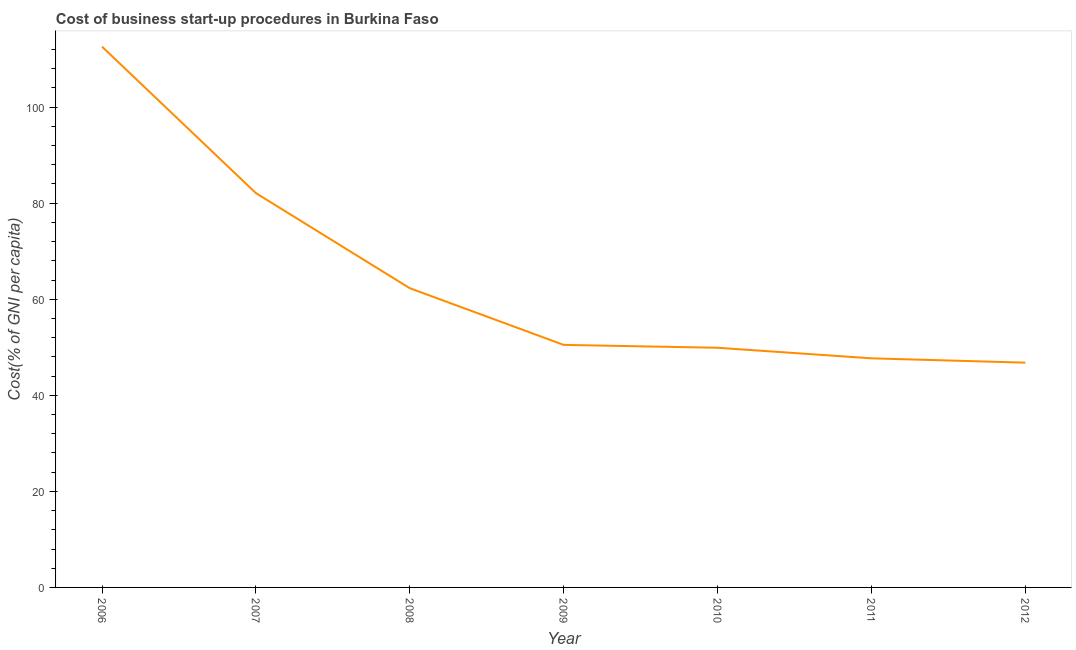What is the cost of business startup procedures in 2011?
Your answer should be very brief. 47.7. Across all years, what is the maximum cost of business startup procedures?
Your answer should be very brief. 112.6. Across all years, what is the minimum cost of business startup procedures?
Offer a very short reply. 46.8. In which year was the cost of business startup procedures minimum?
Offer a very short reply. 2012. What is the sum of the cost of business startup procedures?
Keep it short and to the point. 451.9. What is the difference between the cost of business startup procedures in 2007 and 2010?
Your response must be concise. 32.2. What is the average cost of business startup procedures per year?
Provide a short and direct response. 64.56. What is the median cost of business startup procedures?
Keep it short and to the point. 50.5. In how many years, is the cost of business startup procedures greater than 68 %?
Your answer should be very brief. 2. What is the ratio of the cost of business startup procedures in 2007 to that in 2008?
Keep it short and to the point. 1.32. Is the cost of business startup procedures in 2009 less than that in 2011?
Provide a succinct answer. No. Is the difference between the cost of business startup procedures in 2009 and 2010 greater than the difference between any two years?
Your answer should be very brief. No. What is the difference between the highest and the second highest cost of business startup procedures?
Provide a succinct answer. 30.5. What is the difference between the highest and the lowest cost of business startup procedures?
Your response must be concise. 65.8. Does the graph contain any zero values?
Provide a succinct answer. No. What is the title of the graph?
Give a very brief answer. Cost of business start-up procedures in Burkina Faso. What is the label or title of the Y-axis?
Keep it short and to the point. Cost(% of GNI per capita). What is the Cost(% of GNI per capita) of 2006?
Provide a short and direct response. 112.6. What is the Cost(% of GNI per capita) of 2007?
Your answer should be very brief. 82.1. What is the Cost(% of GNI per capita) in 2008?
Provide a short and direct response. 62.3. What is the Cost(% of GNI per capita) of 2009?
Your answer should be very brief. 50.5. What is the Cost(% of GNI per capita) of 2010?
Make the answer very short. 49.9. What is the Cost(% of GNI per capita) of 2011?
Offer a very short reply. 47.7. What is the Cost(% of GNI per capita) of 2012?
Provide a succinct answer. 46.8. What is the difference between the Cost(% of GNI per capita) in 2006 and 2007?
Your response must be concise. 30.5. What is the difference between the Cost(% of GNI per capita) in 2006 and 2008?
Ensure brevity in your answer.  50.3. What is the difference between the Cost(% of GNI per capita) in 2006 and 2009?
Provide a short and direct response. 62.1. What is the difference between the Cost(% of GNI per capita) in 2006 and 2010?
Offer a very short reply. 62.7. What is the difference between the Cost(% of GNI per capita) in 2006 and 2011?
Offer a very short reply. 64.9. What is the difference between the Cost(% of GNI per capita) in 2006 and 2012?
Ensure brevity in your answer.  65.8. What is the difference between the Cost(% of GNI per capita) in 2007 and 2008?
Your answer should be very brief. 19.8. What is the difference between the Cost(% of GNI per capita) in 2007 and 2009?
Your answer should be compact. 31.6. What is the difference between the Cost(% of GNI per capita) in 2007 and 2010?
Your response must be concise. 32.2. What is the difference between the Cost(% of GNI per capita) in 2007 and 2011?
Your answer should be very brief. 34.4. What is the difference between the Cost(% of GNI per capita) in 2007 and 2012?
Make the answer very short. 35.3. What is the difference between the Cost(% of GNI per capita) in 2008 and 2009?
Ensure brevity in your answer.  11.8. What is the difference between the Cost(% of GNI per capita) in 2008 and 2011?
Give a very brief answer. 14.6. What is the difference between the Cost(% of GNI per capita) in 2010 and 2011?
Your response must be concise. 2.2. What is the ratio of the Cost(% of GNI per capita) in 2006 to that in 2007?
Give a very brief answer. 1.37. What is the ratio of the Cost(% of GNI per capita) in 2006 to that in 2008?
Ensure brevity in your answer.  1.81. What is the ratio of the Cost(% of GNI per capita) in 2006 to that in 2009?
Your response must be concise. 2.23. What is the ratio of the Cost(% of GNI per capita) in 2006 to that in 2010?
Keep it short and to the point. 2.26. What is the ratio of the Cost(% of GNI per capita) in 2006 to that in 2011?
Provide a succinct answer. 2.36. What is the ratio of the Cost(% of GNI per capita) in 2006 to that in 2012?
Provide a succinct answer. 2.41. What is the ratio of the Cost(% of GNI per capita) in 2007 to that in 2008?
Your response must be concise. 1.32. What is the ratio of the Cost(% of GNI per capita) in 2007 to that in 2009?
Provide a short and direct response. 1.63. What is the ratio of the Cost(% of GNI per capita) in 2007 to that in 2010?
Make the answer very short. 1.65. What is the ratio of the Cost(% of GNI per capita) in 2007 to that in 2011?
Keep it short and to the point. 1.72. What is the ratio of the Cost(% of GNI per capita) in 2007 to that in 2012?
Your response must be concise. 1.75. What is the ratio of the Cost(% of GNI per capita) in 2008 to that in 2009?
Offer a terse response. 1.23. What is the ratio of the Cost(% of GNI per capita) in 2008 to that in 2010?
Your response must be concise. 1.25. What is the ratio of the Cost(% of GNI per capita) in 2008 to that in 2011?
Provide a short and direct response. 1.31. What is the ratio of the Cost(% of GNI per capita) in 2008 to that in 2012?
Provide a short and direct response. 1.33. What is the ratio of the Cost(% of GNI per capita) in 2009 to that in 2011?
Ensure brevity in your answer.  1.06. What is the ratio of the Cost(% of GNI per capita) in 2009 to that in 2012?
Ensure brevity in your answer.  1.08. What is the ratio of the Cost(% of GNI per capita) in 2010 to that in 2011?
Offer a terse response. 1.05. What is the ratio of the Cost(% of GNI per capita) in 2010 to that in 2012?
Offer a terse response. 1.07. What is the ratio of the Cost(% of GNI per capita) in 2011 to that in 2012?
Offer a very short reply. 1.02. 